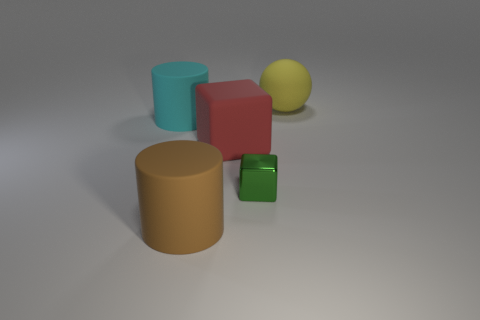Add 2 cyan cylinders. How many objects exist? 7 Subtract all cubes. How many objects are left? 3 Add 3 red rubber objects. How many red rubber objects are left? 4 Add 4 cyan matte objects. How many cyan matte objects exist? 5 Subtract 0 purple spheres. How many objects are left? 5 Subtract all tiny green shiny things. Subtract all large red rubber things. How many objects are left? 3 